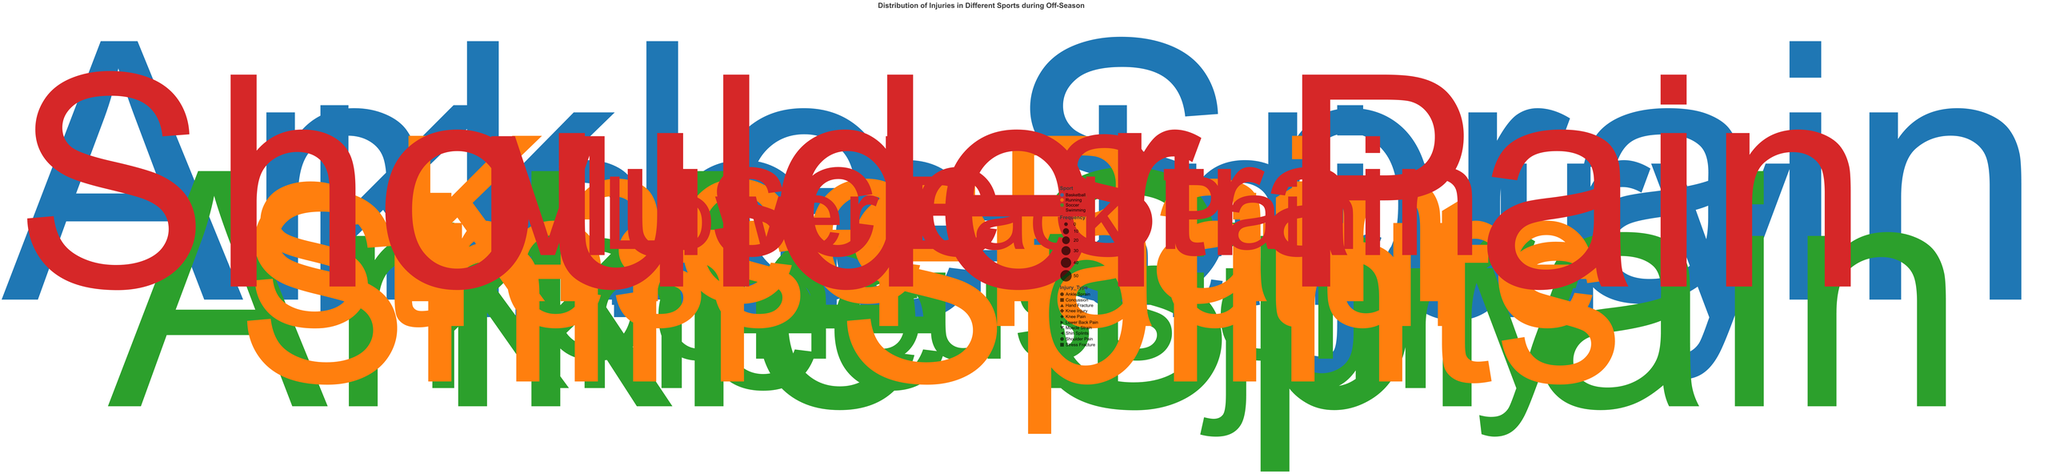What sport has the highest frequency of injuries for a single injury type? The highest frequency of injuries for a single injury type can be observed by identifying the largest point on the chart. This point, located at the 30-degree angle, represents Basketball with Ankle Sprain injuries that have a frequency of 50.
Answer: Basketball Which injury type in Swimming has the lowest frequency? Observe the points labeled under Swimming. The point at the 0-degree angle represents Lower Back Pain with a frequency of 10, making it the lowest frequency injury type for Swimming.
Answer: Lower Back Pain Compare the frequency of Ankle Sprains in Basketball vs Soccer. Which has more? Locate the points for Ankle Sprain in Basketball and Soccer. Basketball's Ankle Sprain is at the 30-degree angle with a frequency of 50, while Soccer's Ankle Sprain is at the 120-degree angle with a frequency of 45. Thus, Basketball has more Ankle Sprains.
Answer: Basketball What are the injury types in Running and their corresponding frequencies? Identify the points under the Running category. The injury types and frequencies are: Shin Splints (35) at 210 degrees, Stress Fracture (25) at 240 degrees, and Knee Pain (30) at 270 degrees.
Answer: Shin Splints: 35, Stress Fracture: 25, Knee Pain: 30 Which sport has the most diverse types of injuries? Count the distinct injury types for each sport by noting how many unique shapes are present for each color. Basketball has 3 types, Soccer has 3, Running has 3, and Swimming has 3. Thus, all sports have the same number of diverse injury types (3).
Answer: Basketball, Soccer, Running, Swimming Which two injury types in Basketball have a combined frequency of 55? Check the points representing Basketball. Ankle Sprain (50) at 30 degrees and Hand Fracture (15) at 90 degrees sum up to 65. None sum to 55. This means there’s no combination summing to 55 in Basketball.
Answer: None What is the frequency of Knee Injuries across all sports? Add the frequencies of Knee Injuries across all sports. Basketball has 40 (at 60 degrees), Soccer has 30 (at 150 degrees), and Running has 30 (at 270 degrees). The total is 40 + 30 + 30 = 100.
Answer: 100 